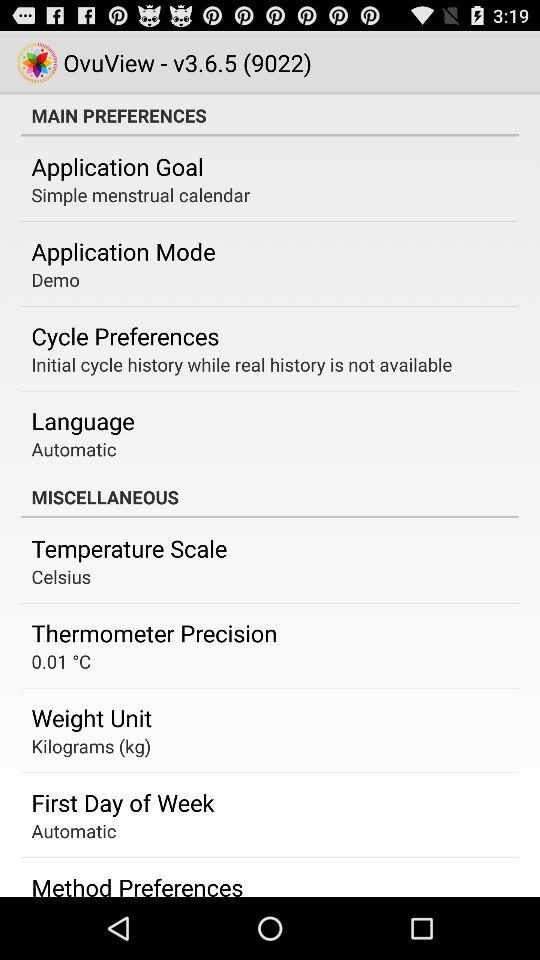What is the mode of the application? The mode of the application is "Demo". 